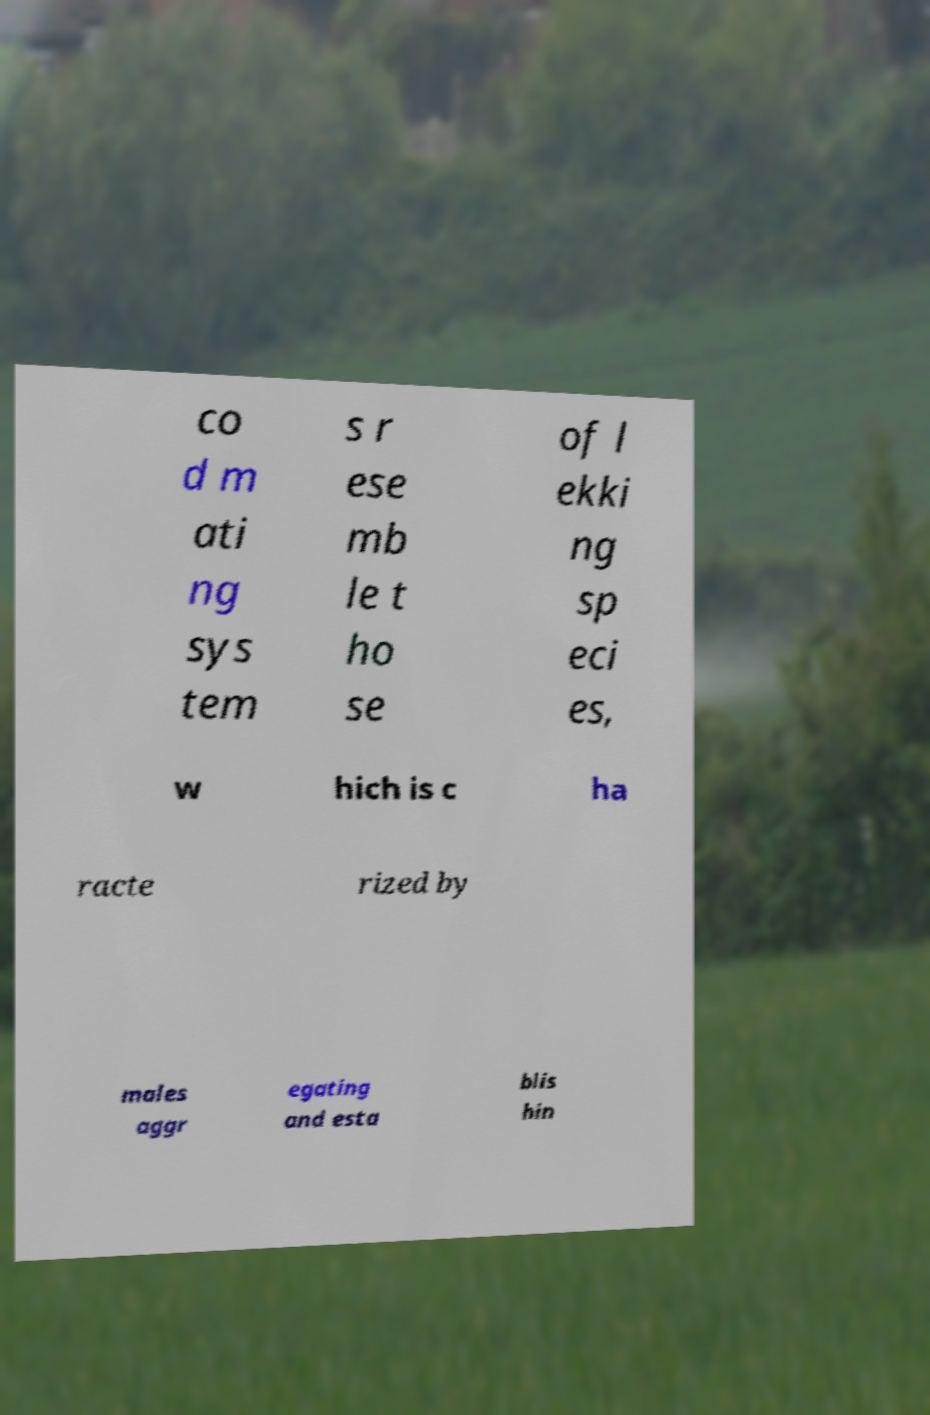Please read and relay the text visible in this image. What does it say? co d m ati ng sys tem s r ese mb le t ho se of l ekki ng sp eci es, w hich is c ha racte rized by males aggr egating and esta blis hin 